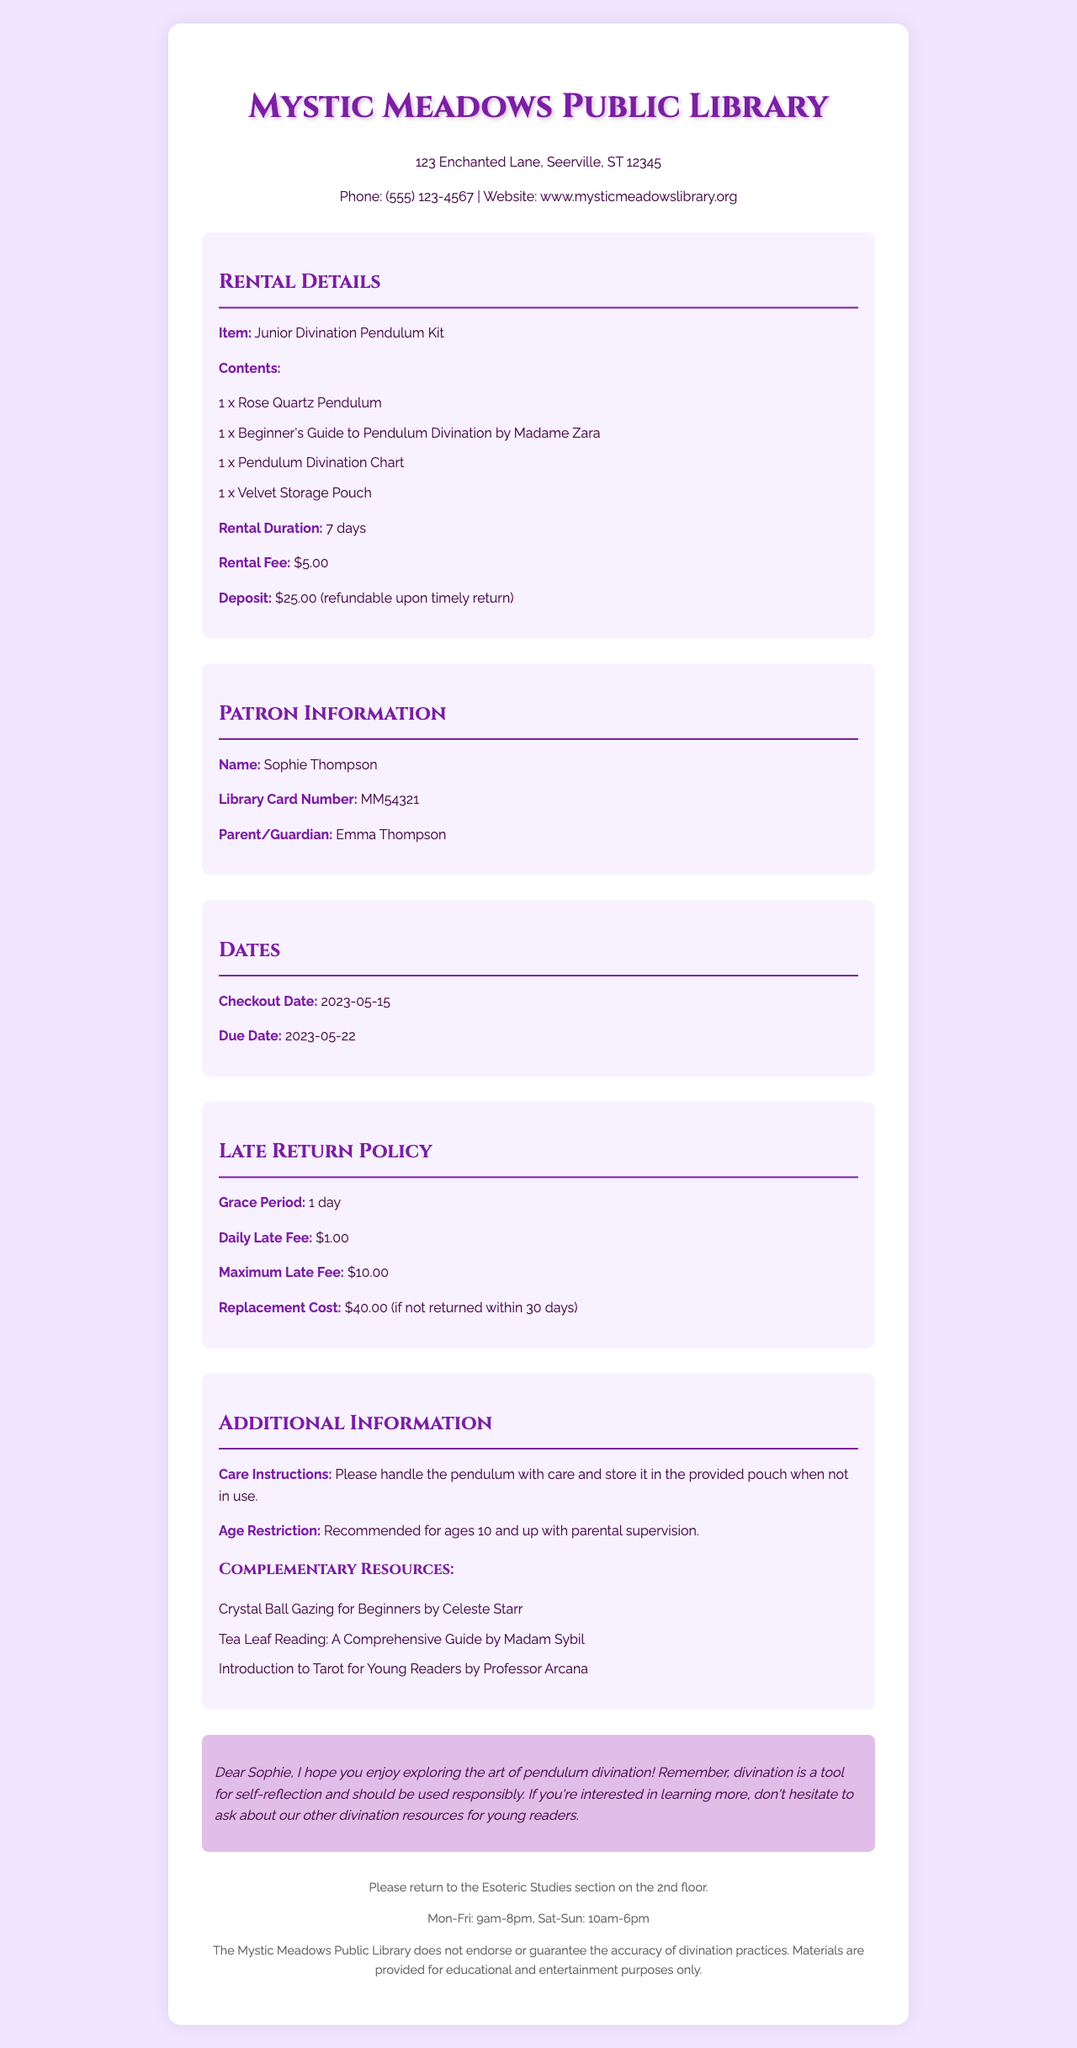What is the name of the library? The document states the name of the library at the top of the receipt.
Answer: Mystic Meadows Public Library What is the rental fee for the pendulum kit? The rental fee is specified in the rental details section of the receipt.
Answer: $5.00 Who is the patron's parent or guardian? The patron's parent or guardian's name is listed in the patron information section.
Answer: Emma Thompson What is the due date for returning the kit? The due date is provided in the dates section of the document.
Answer: 2023-05-22 What is the daily late fee according to the policy? The daily late fee is mentioned in the late return policy section of the receipt.
Answer: $1.00 What is the maximum late fee that can be charged? The maximum late fee is outlined in the late return policy section.
Answer: $10.00 What is included in the pendulum kit? The contents of the rental kit are listed under rental details.
Answer: 1 x Rose Quartz Pendulum, 1 x Beginner's Guide to Pendulum Divination by Madame Zara, 1 x Pendulum Divination Chart, 1 x Velvet Storage Pouch How long can the kit be rented for? The rental duration is specified in the rental details portion of the receipt.
Answer: 7 days What is the replacement cost if the kit is not returned? The replacement cost is outlined in the late return policy section.
Answer: $40.00 (if not returned within 30 days) 